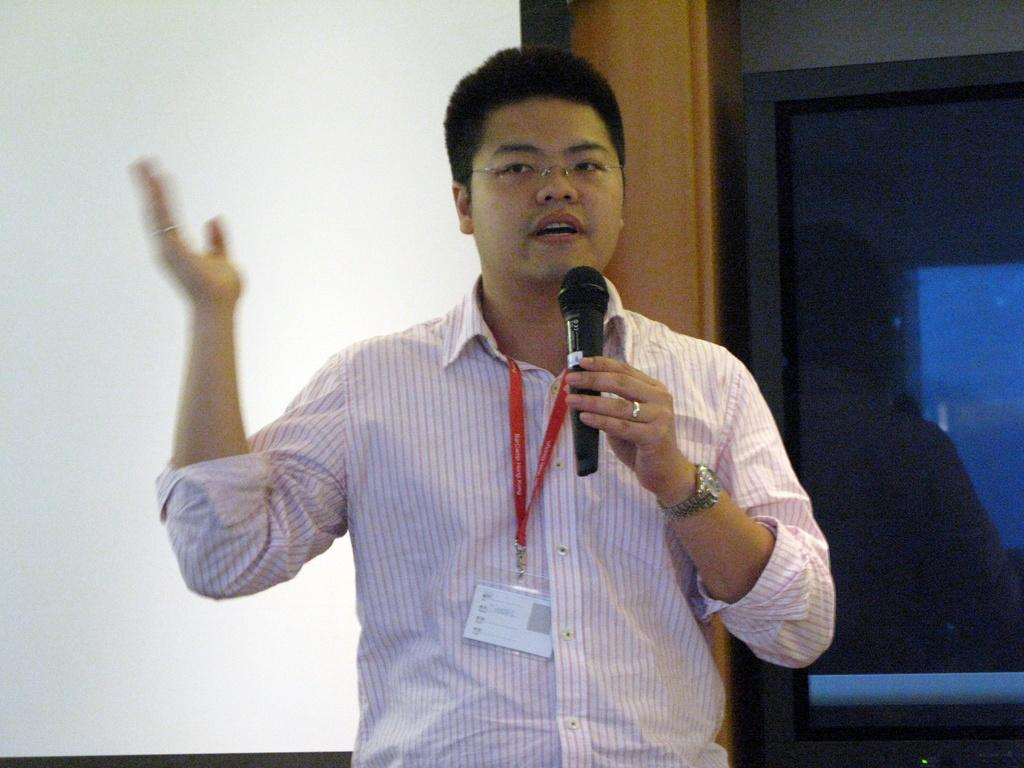What is the main subject in the foreground of the image? There is a person in the foreground of the image. What is the person holding in their hand? The person is holding a microphone in their hand. What can be seen in the background of the image? There is a screen, a wall, a pillar, and a glass object in the background of the image. What type of location might the image have been taken in? The image may have been taken in a hall. Can you tell me how many houses are visible in the image? There are no houses visible in the image. What type of drain is present in the image? There is no drain present in the image. 